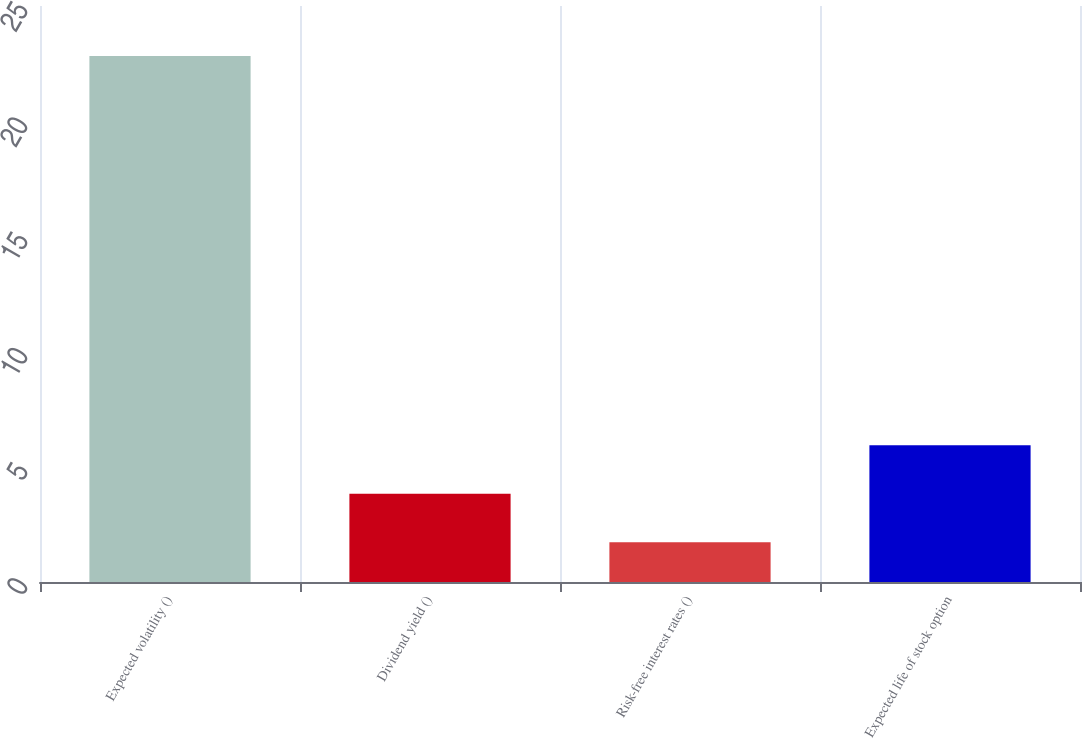Convert chart. <chart><loc_0><loc_0><loc_500><loc_500><bar_chart><fcel>Expected volatility ()<fcel>Dividend yield ()<fcel>Risk-free interest rates ()<fcel>Expected life of stock option<nl><fcel>22.83<fcel>3.83<fcel>1.72<fcel>5.94<nl></chart> 